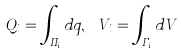<formula> <loc_0><loc_0><loc_500><loc_500>Q _ { i } = \int _ { \Pi _ { i } } d q , \ V _ { i } = \int _ { \Gamma _ { i } } d V</formula> 